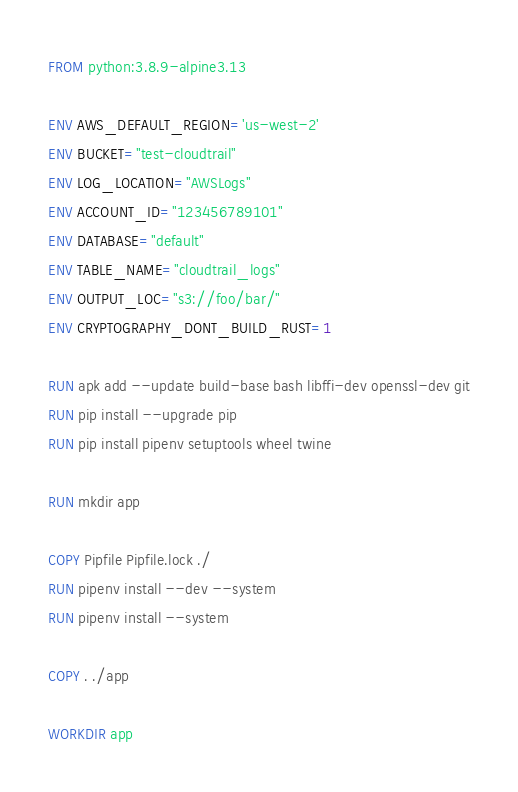Convert code to text. <code><loc_0><loc_0><loc_500><loc_500><_Dockerfile_>FROM python:3.8.9-alpine3.13

ENV AWS_DEFAULT_REGION='us-west-2'
ENV BUCKET="test-cloudtrail"
ENV LOG_LOCATION="AWSLogs"
ENV ACCOUNT_ID="123456789101"
ENV DATABASE="default"
ENV TABLE_NAME="cloudtrail_logs"
ENV OUTPUT_LOC="s3://foo/bar/"
ENV CRYPTOGRAPHY_DONT_BUILD_RUST=1

RUN apk add --update build-base bash libffi-dev openssl-dev git
RUN pip install --upgrade pip
RUN pip install pipenv setuptools wheel twine

RUN mkdir app

COPY Pipfile Pipfile.lock ./
RUN pipenv install --dev --system
RUN pipenv install --system

COPY . ./app

WORKDIR app
</code> 